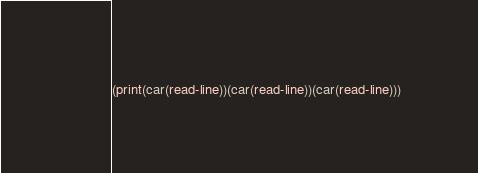Convert code to text. <code><loc_0><loc_0><loc_500><loc_500><_Scheme_>(print(car(read-line))(car(read-line))(car(read-line)))</code> 